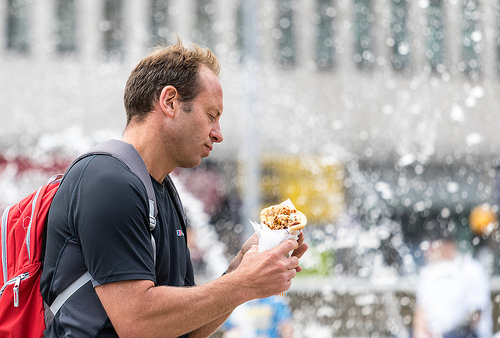<image>
Is there a food on the water? No. The food is not positioned on the water. They may be near each other, but the food is not supported by or resting on top of the water. 